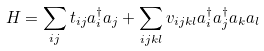<formula> <loc_0><loc_0><loc_500><loc_500>H = \sum _ { i j } t _ { i j } a ^ { \dag } _ { i } a _ { j } + \sum _ { i j k l } v _ { i j k l } a ^ { \dag } _ { i } a ^ { \dag } _ { j } a _ { k } a _ { l }</formula> 